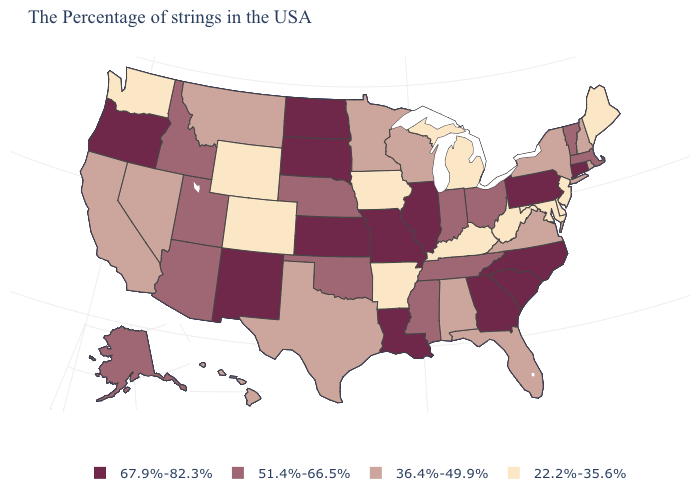Which states have the highest value in the USA?
Answer briefly. Connecticut, Pennsylvania, North Carolina, South Carolina, Georgia, Illinois, Louisiana, Missouri, Kansas, South Dakota, North Dakota, New Mexico, Oregon. Does Ohio have a lower value than Florida?
Answer briefly. No. Does Missouri have the highest value in the MidWest?
Keep it brief. Yes. Which states have the lowest value in the South?
Be succinct. Delaware, Maryland, West Virginia, Kentucky, Arkansas. Among the states that border Tennessee , which have the lowest value?
Short answer required. Kentucky, Arkansas. Name the states that have a value in the range 67.9%-82.3%?
Keep it brief. Connecticut, Pennsylvania, North Carolina, South Carolina, Georgia, Illinois, Louisiana, Missouri, Kansas, South Dakota, North Dakota, New Mexico, Oregon. Does the map have missing data?
Concise answer only. No. What is the lowest value in the Northeast?
Write a very short answer. 22.2%-35.6%. What is the value of Ohio?
Short answer required. 51.4%-66.5%. Name the states that have a value in the range 67.9%-82.3%?
Be succinct. Connecticut, Pennsylvania, North Carolina, South Carolina, Georgia, Illinois, Louisiana, Missouri, Kansas, South Dakota, North Dakota, New Mexico, Oregon. Name the states that have a value in the range 22.2%-35.6%?
Be succinct. Maine, New Jersey, Delaware, Maryland, West Virginia, Michigan, Kentucky, Arkansas, Iowa, Wyoming, Colorado, Washington. Name the states that have a value in the range 36.4%-49.9%?
Quick response, please. Rhode Island, New Hampshire, New York, Virginia, Florida, Alabama, Wisconsin, Minnesota, Texas, Montana, Nevada, California, Hawaii. How many symbols are there in the legend?
Give a very brief answer. 4. What is the value of Louisiana?
Quick response, please. 67.9%-82.3%. 